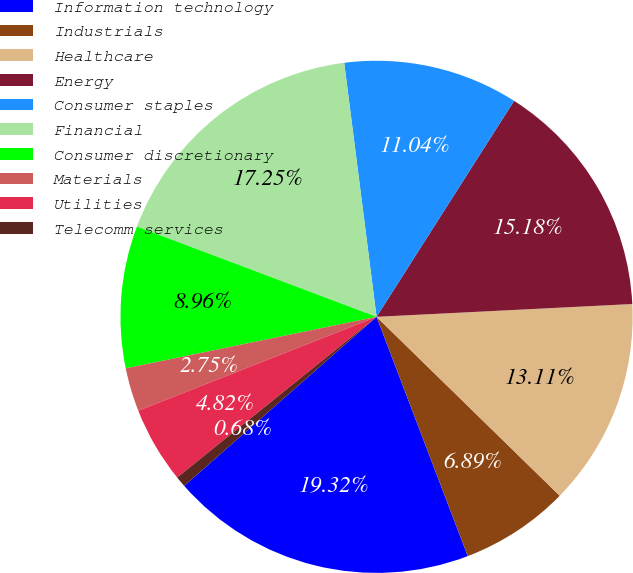Convert chart. <chart><loc_0><loc_0><loc_500><loc_500><pie_chart><fcel>Information technology<fcel>Industrials<fcel>Healthcare<fcel>Energy<fcel>Consumer staples<fcel>Financial<fcel>Consumer discretionary<fcel>Materials<fcel>Utilities<fcel>Telecomm services<nl><fcel>19.32%<fcel>6.89%<fcel>13.11%<fcel>15.18%<fcel>11.04%<fcel>17.25%<fcel>8.96%<fcel>2.75%<fcel>4.82%<fcel>0.68%<nl></chart> 